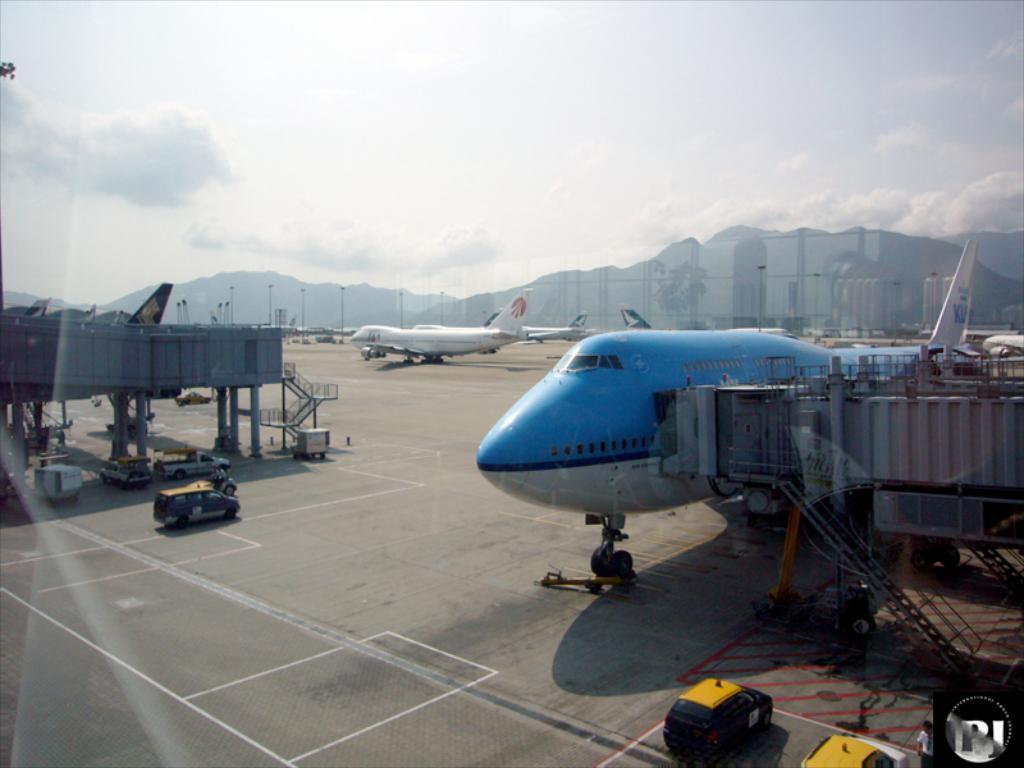How would you summarize this image in a sentence or two? In this image we can see aeroplanes on the road. There are vehicles. In the background of the image there are mountains. There are clouds at the top of the image. There are clouds. 